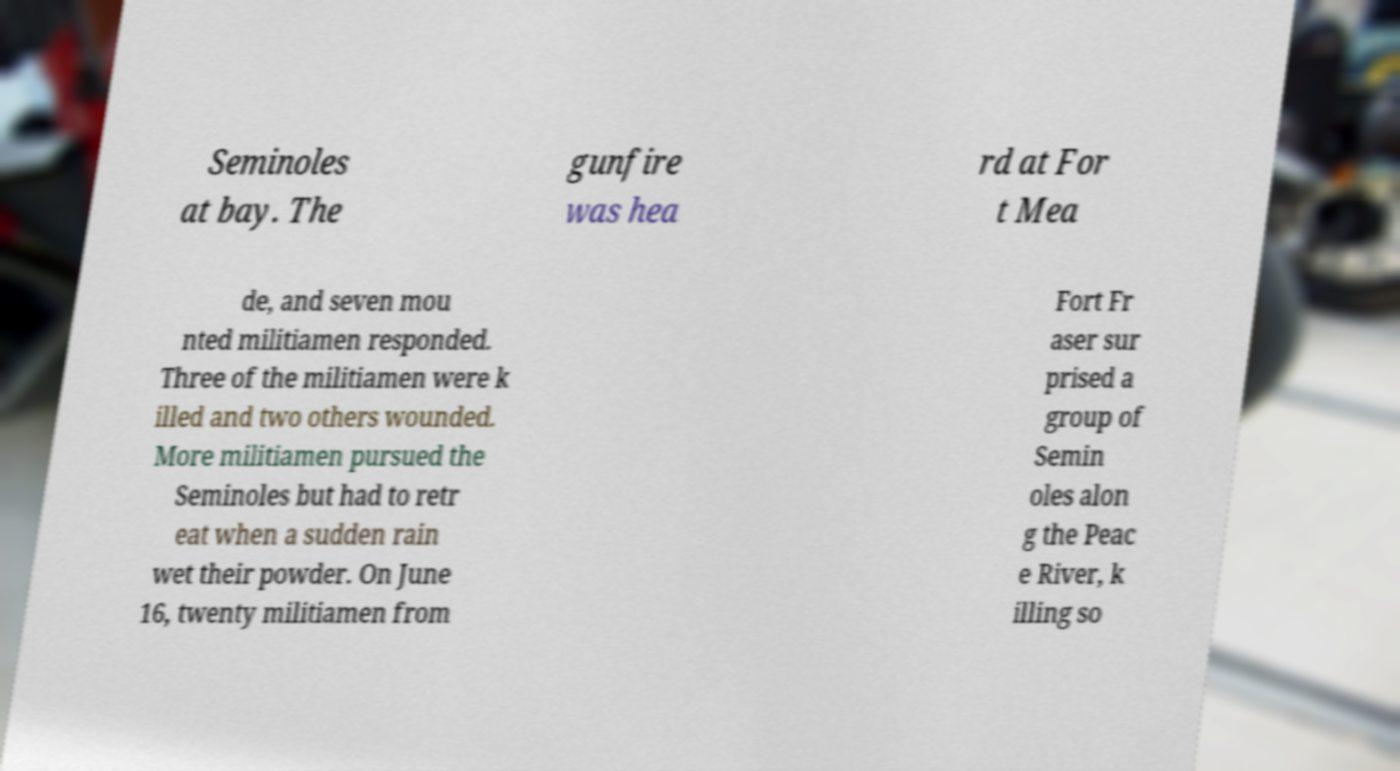Can you read and provide the text displayed in the image?This photo seems to have some interesting text. Can you extract and type it out for me? Seminoles at bay. The gunfire was hea rd at For t Mea de, and seven mou nted militiamen responded. Three of the militiamen were k illed and two others wounded. More militiamen pursued the Seminoles but had to retr eat when a sudden rain wet their powder. On June 16, twenty militiamen from Fort Fr aser sur prised a group of Semin oles alon g the Peac e River, k illing so 